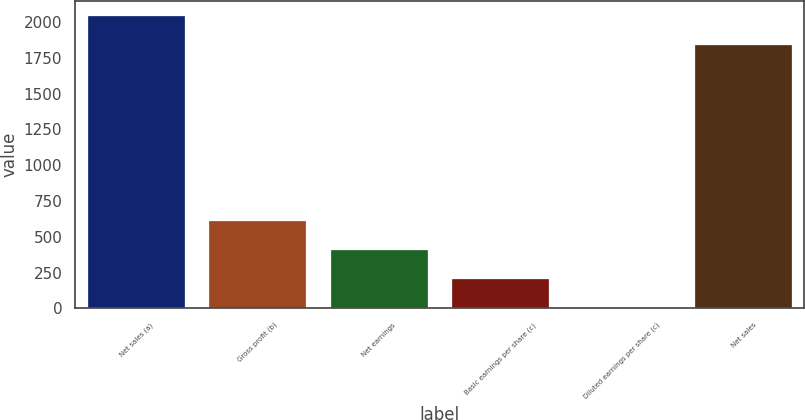Convert chart. <chart><loc_0><loc_0><loc_500><loc_500><bar_chart><fcel>Net sales (a)<fcel>Gross profit (b)<fcel>Net earnings<fcel>Basic earnings per share (c)<fcel>Diluted earnings per share (c)<fcel>Net sales<nl><fcel>2045.68<fcel>610.57<fcel>407.39<fcel>204.21<fcel>1.03<fcel>1842.5<nl></chart> 